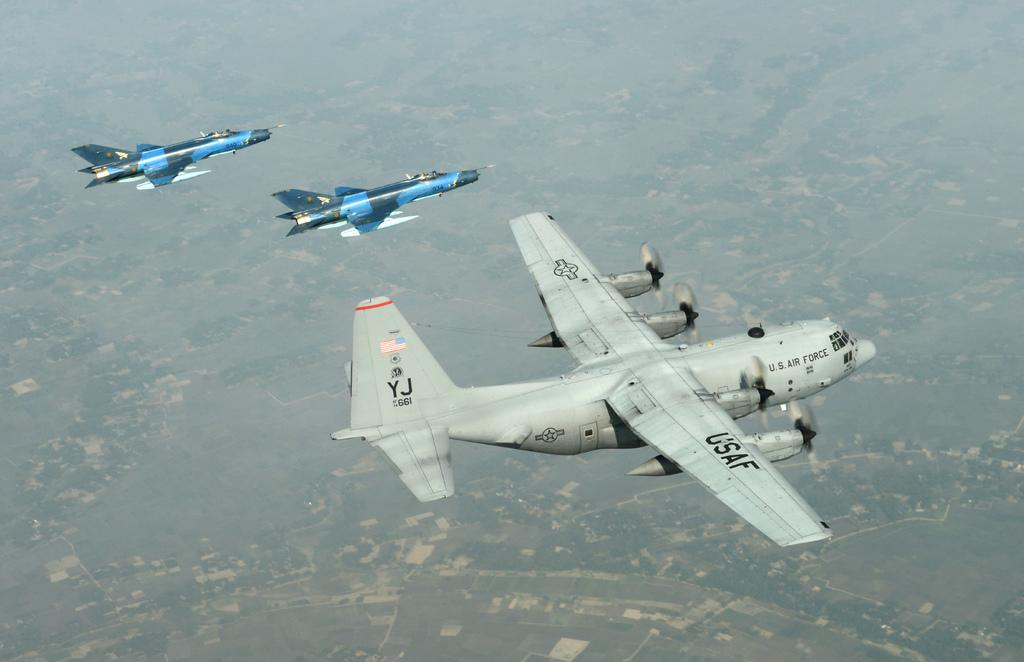Provide a one-sentence caption for the provided image. A U.S. Air Force gray jet is flying next to two smaller blue jets. 